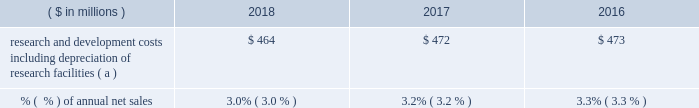18 2018 ppg annual report and 10-k research and development .
( a ) prior year amounts have been recast for the adoption of accounting standards update no .
2017-07 , "improving the presentation of net periodic pension cost and net periodic postretirement benefit cost . 201d see note 1 within item 8 of this form 10-k for additional information .
Technology innovation has been a hallmark of ppg 2019s success throughout its history .
The company seeks to optimize its investment in research and development to create new products to drive profitable growth .
We align our product development with the macro trends in the markets we serve and leverage core technology platforms to develop products for unmet market needs .
Our history of successful technology introductions is based on a commitment to an efficient and effective innovation process and disciplined portfolio management .
We have obtained government funding for a small portion of the company 2019s research efforts , and we will continue to pursue government funding where appropriate .
Ppg owns and operates several facilities to conduct research and development for new and improved products and processes .
In addition to the company 2019s centralized principal research and development centers ( see item 2 .
201cproperties 201d of this form 10-k ) , operating segments manage their development through centers of excellence .
As part of our ongoing efforts to manage our formulations and raw material costs effectively , we operate a global competitive sourcing laboratory in china .
Because of the company 2019s broad array of products and customers , ppg is not materially dependent upon any single technology platform .
Raw materials and energy the effective management of raw materials and energy is important to ppg 2019s continued success .
Ppg uses a wide variety of complex raw materials that serve as the building blocks of our manufactured products that provide broad ranging , high performance solutions to our customers .
The company 2019s most significant raw materials are epoxy and other resins , titanium dioxide and other pigments , and solvents in the coatings businesses and sand and soda ash for the specialty coatings and materials business .
Coatings raw materials include both organic , primarily petroleum-derived , materials and inorganic materials , including titanium dioxide .
These raw materials represent ppg 2019s single largest production cost component .
Most of the raw materials and energy used in production are purchased from outside sources , and the company has made , and plans to continue to make , supply arrangements to meet our planned operating requirements for the future .
Supply of critical raw materials and energy is managed by establishing contracts with multiple sources , and identifying alternative materials or technology whenever possible .
Our products use both petroleum-derived and bio-based materials as part of a product renewal strategy .
While prices for these raw materials typically fluctuate with energy prices and global supply and demand , such fluctuations are impacted by the fact that the manufacture of our raw materials is several steps downstream from crude oil and natural gas .
The company is continuing its aggressive sourcing initiatives to broaden our supply of high quality raw materials .
These initiatives include qualifying multiple and local sources of supply , including suppliers from asia and other lower cost regions of the world , adding on-site resin production at certain manufacturing locations and a reduction in the amount of titanium dioxide used in our product formulations .
We are subject to existing and evolving standards relating to the registration of chemicals which could potentially impact the availability and viability of some of the raw materials we use in our production processes .
Our ongoing , global product stewardship efforts are directed at maintaining our compliance with these standards .
Ppg has joined a global initiative to eliminate child labor from the mica industry , and the company is continuing to take steps , including audits of our suppliers , to ensure compliance with ppg 2019s zero-tolerance policy against the use of child labor in their supply chains .
Changes to chemical registration regulations have been proposed or implemented in the eu and many other countries , including china , canada , the united states ( u.s. ) , brazil , mexico and korea .
Because implementation of many of these programs has not been finalized , the financial impact cannot be estimated at this time .
We anticipate that the number of chemical registration regulations will continue to increase globally , and we have implemented programs to track and comply with these regulations .
Given the recent volatility in certain energy-based input costs and foreign currencies , the company is not able to predict with certainty the 2019 full year impact of related changes in raw material pricing versus 2018 ; however , ppg currently expects overall coatings raw material costs to increase a low-single-digit percentage in the first half of 2019 , with impacts varied by region and commodity .
Further , given the distribution nature of many of our businesses , logistics and distribution costs are sizable , as are wages and benefits but to a lesser degree .
Ppg typically experiences fluctuating prices for energy and raw materials driven by various factors , including changes in supplier feedstock costs and inventories , global industry activity levels , foreign currency exchange rates , government regulation , and global supply and demand factors .
In aggregate , average .
What was the change in millions of research and development costs including depreciation of research facilities from 2016 to 2017? 
Computations: (472 - 473)
Answer: -1.0. 